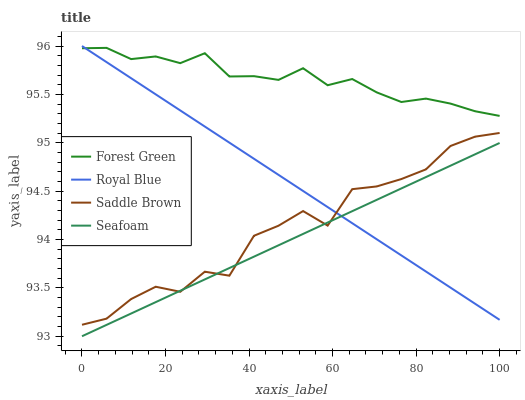Does Seafoam have the minimum area under the curve?
Answer yes or no. Yes. Does Forest Green have the maximum area under the curve?
Answer yes or no. Yes. Does Saddle Brown have the minimum area under the curve?
Answer yes or no. No. Does Saddle Brown have the maximum area under the curve?
Answer yes or no. No. Is Seafoam the smoothest?
Answer yes or no. Yes. Is Saddle Brown the roughest?
Answer yes or no. Yes. Is Forest Green the smoothest?
Answer yes or no. No. Is Forest Green the roughest?
Answer yes or no. No. Does Seafoam have the lowest value?
Answer yes or no. Yes. Does Saddle Brown have the lowest value?
Answer yes or no. No. Does Royal Blue have the highest value?
Answer yes or no. Yes. Does Forest Green have the highest value?
Answer yes or no. No. Is Saddle Brown less than Forest Green?
Answer yes or no. Yes. Is Forest Green greater than Seafoam?
Answer yes or no. Yes. Does Royal Blue intersect Forest Green?
Answer yes or no. Yes. Is Royal Blue less than Forest Green?
Answer yes or no. No. Is Royal Blue greater than Forest Green?
Answer yes or no. No. Does Saddle Brown intersect Forest Green?
Answer yes or no. No. 